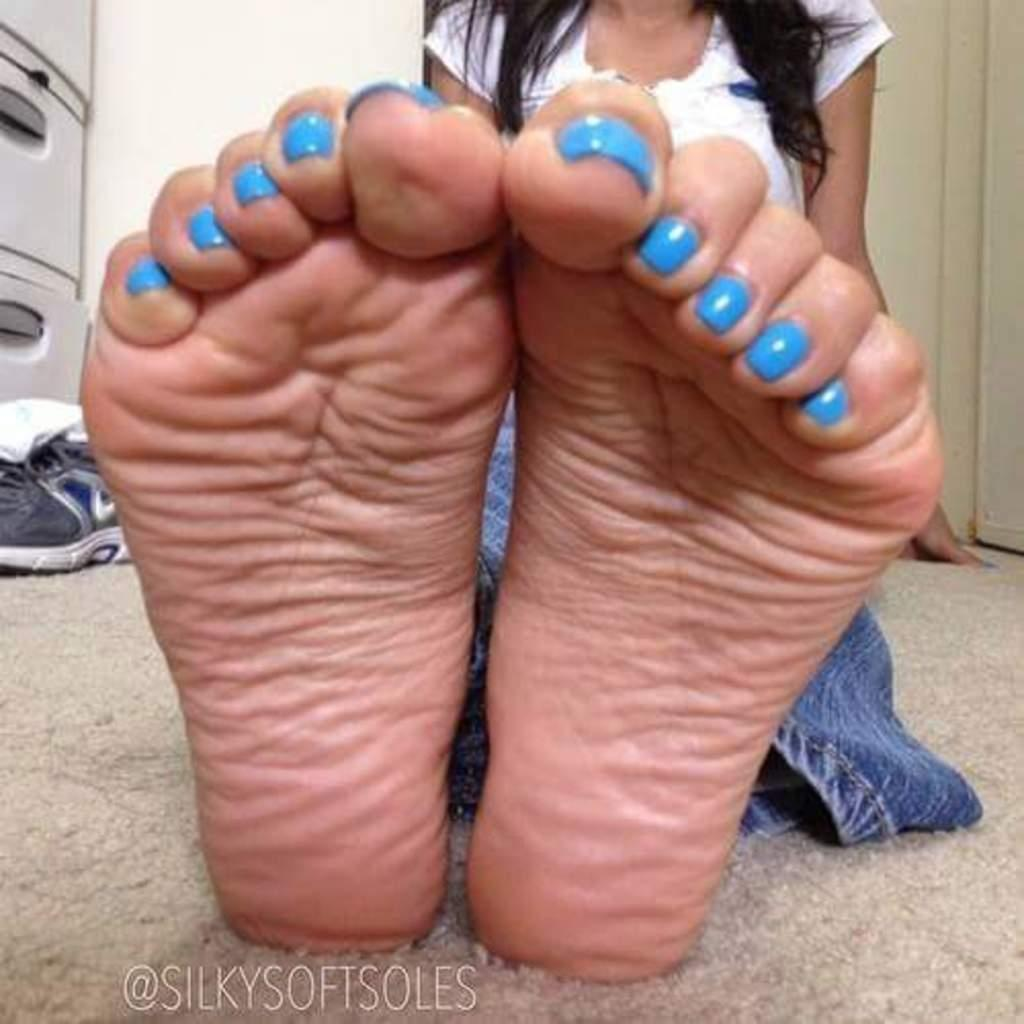Who is present in the image? There is a woman in the image. What is the woman's position in the image? The woman is on the floor. What can be seen in the image besides the woman? There is text and a wall in the background of the image. What other objects are visible in the background? There are shoes and at least one other object in the background of the image. Can you describe the setting of the image? The image may have been taken in a hall. What type of cow can be seen in the image? There is no cow present in the image. Is the sleet visible in the image? The image does not show any sleet; it is an indoor scene with a woman on the floor and a background featuring a wall, shoes, and other objects. 